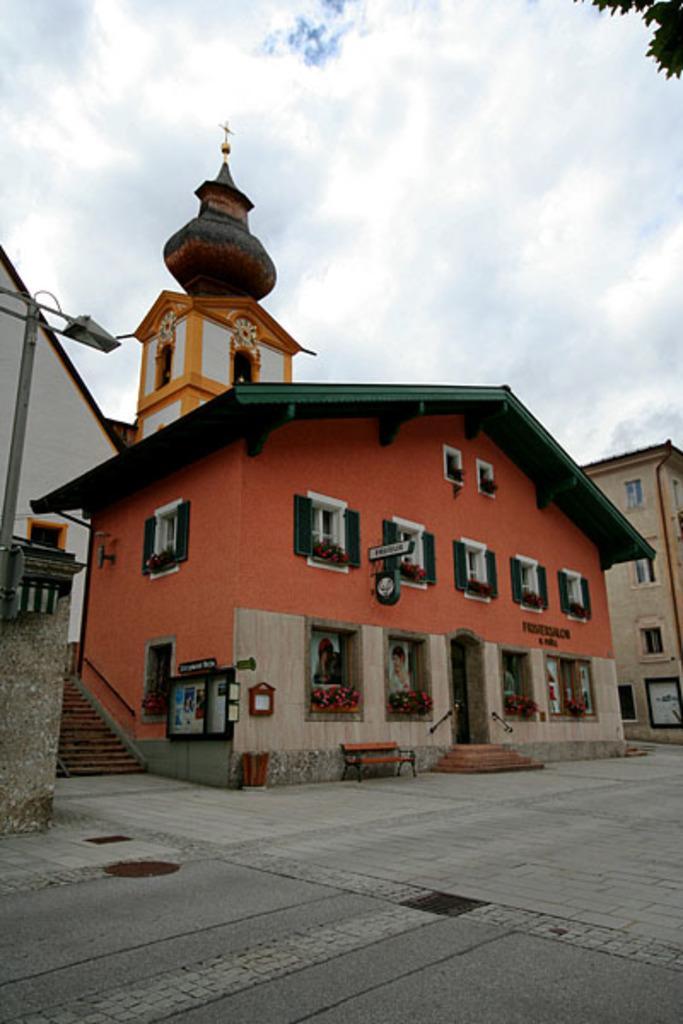Can you describe this image briefly? In this picture we can see houses on the street. The sky is blue. 